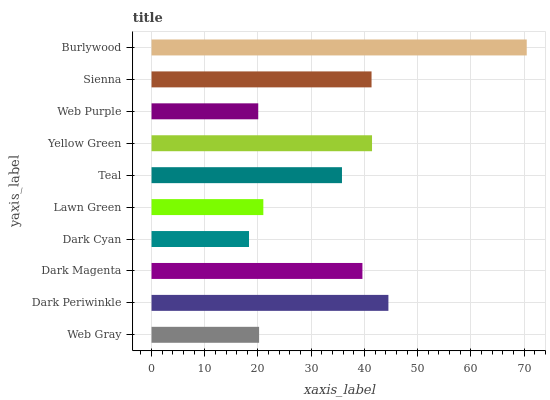Is Dark Cyan the minimum?
Answer yes or no. Yes. Is Burlywood the maximum?
Answer yes or no. Yes. Is Dark Periwinkle the minimum?
Answer yes or no. No. Is Dark Periwinkle the maximum?
Answer yes or no. No. Is Dark Periwinkle greater than Web Gray?
Answer yes or no. Yes. Is Web Gray less than Dark Periwinkle?
Answer yes or no. Yes. Is Web Gray greater than Dark Periwinkle?
Answer yes or no. No. Is Dark Periwinkle less than Web Gray?
Answer yes or no. No. Is Dark Magenta the high median?
Answer yes or no. Yes. Is Teal the low median?
Answer yes or no. Yes. Is Yellow Green the high median?
Answer yes or no. No. Is Dark Periwinkle the low median?
Answer yes or no. No. 